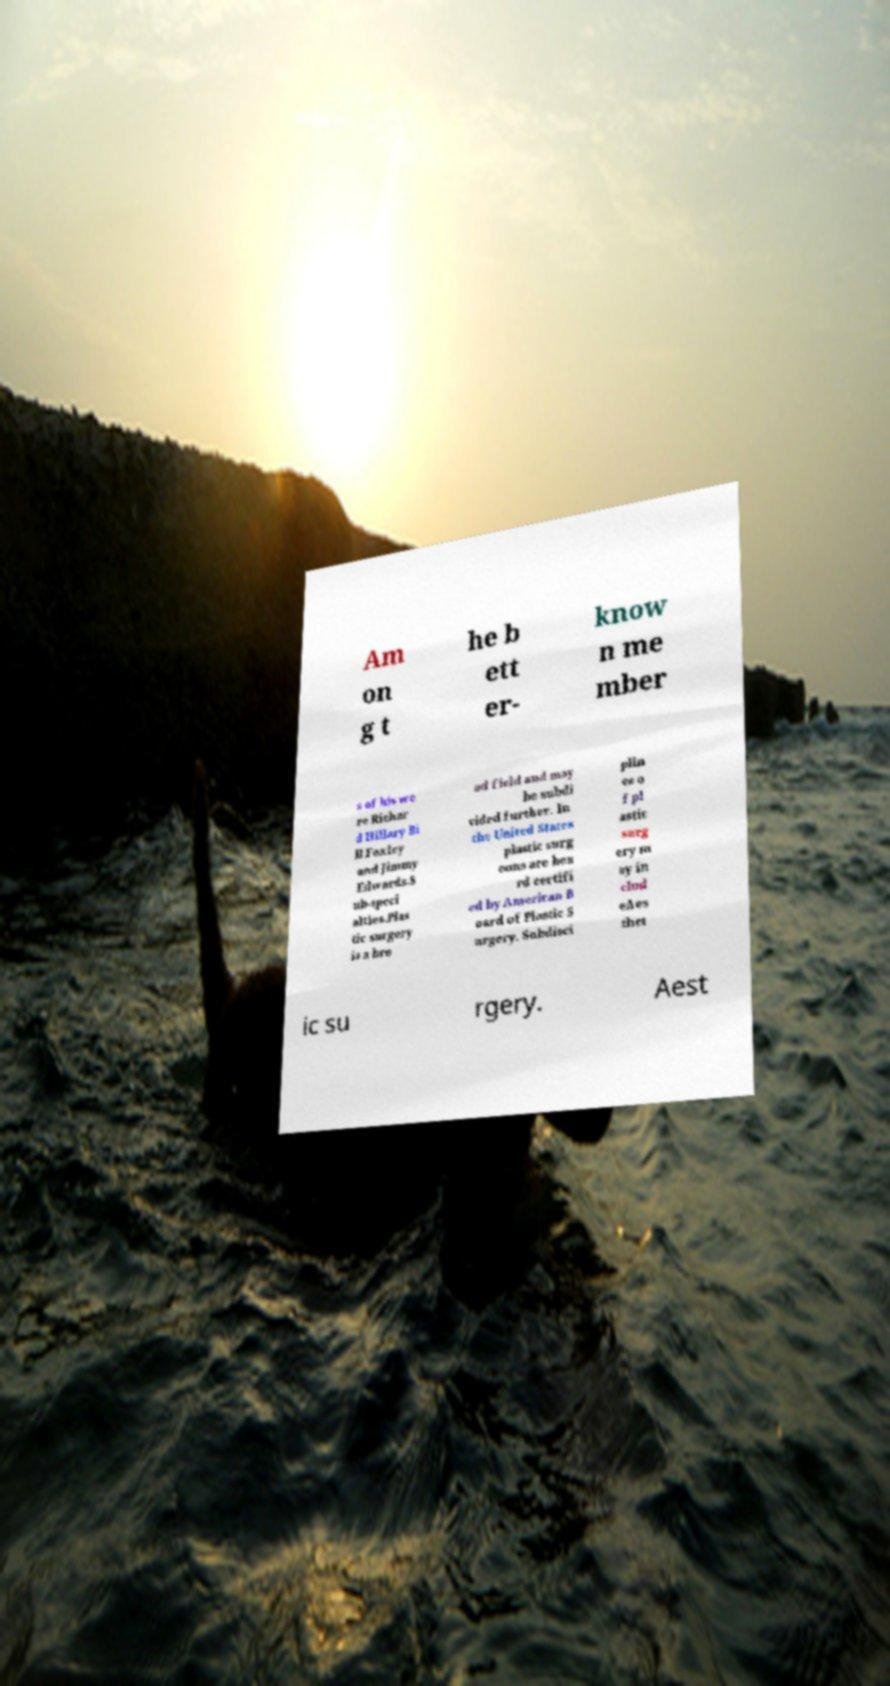For documentation purposes, I need the text within this image transcribed. Could you provide that? Am on g t he b ett er- know n me mber s of his we re Richar d Hillary Bi ll Foxley and Jimmy Edwards.S ub-speci alties.Plas tic surgery is a bro ad field and may be subdi vided further. In the United States plastic surg eons are boa rd certifi ed by American B oard of Plastic S urgery. Subdisci plin es o f pl astic surg ery m ay in clud eAes thet ic su rgery. Aest 